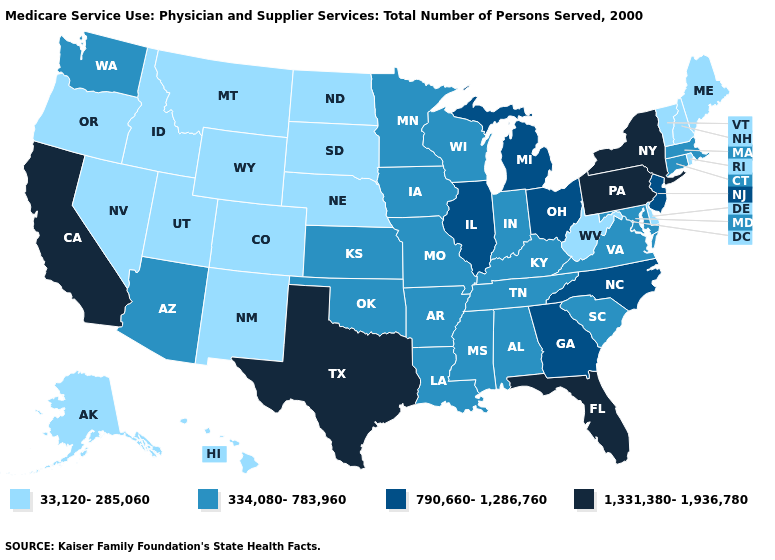Does Hawaii have a lower value than North Carolina?
Concise answer only. Yes. Among the states that border South Dakota , which have the lowest value?
Keep it brief. Montana, Nebraska, North Dakota, Wyoming. Among the states that border Maryland , does Virginia have the highest value?
Be succinct. No. What is the value of Michigan?
Short answer required. 790,660-1,286,760. What is the value of Louisiana?
Concise answer only. 334,080-783,960. How many symbols are there in the legend?
Keep it brief. 4. What is the lowest value in states that border New Mexico?
Concise answer only. 33,120-285,060. What is the value of Rhode Island?
Keep it brief. 33,120-285,060. What is the lowest value in states that border Wisconsin?
Quick response, please. 334,080-783,960. Name the states that have a value in the range 33,120-285,060?
Give a very brief answer. Alaska, Colorado, Delaware, Hawaii, Idaho, Maine, Montana, Nebraska, Nevada, New Hampshire, New Mexico, North Dakota, Oregon, Rhode Island, South Dakota, Utah, Vermont, West Virginia, Wyoming. Name the states that have a value in the range 790,660-1,286,760?
Quick response, please. Georgia, Illinois, Michigan, New Jersey, North Carolina, Ohio. What is the value of Colorado?
Concise answer only. 33,120-285,060. Which states have the lowest value in the MidWest?
Quick response, please. Nebraska, North Dakota, South Dakota. Name the states that have a value in the range 334,080-783,960?
Keep it brief. Alabama, Arizona, Arkansas, Connecticut, Indiana, Iowa, Kansas, Kentucky, Louisiana, Maryland, Massachusetts, Minnesota, Mississippi, Missouri, Oklahoma, South Carolina, Tennessee, Virginia, Washington, Wisconsin. How many symbols are there in the legend?
Answer briefly. 4. 